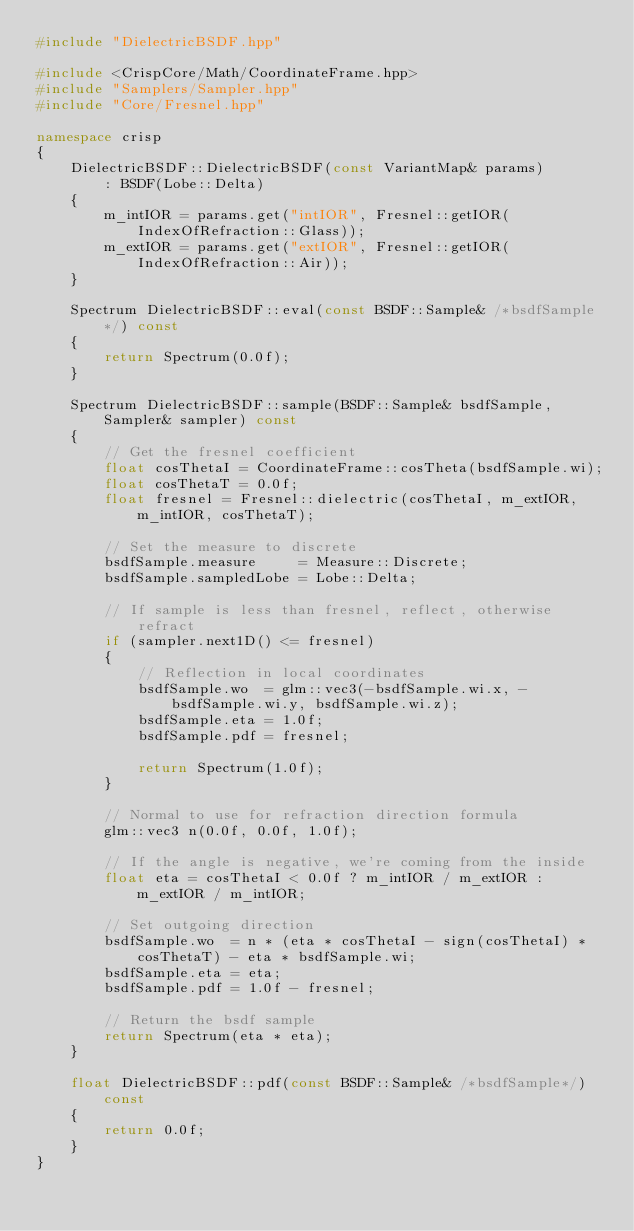Convert code to text. <code><loc_0><loc_0><loc_500><loc_500><_C++_>#include "DielectricBSDF.hpp"

#include <CrispCore/Math/CoordinateFrame.hpp>
#include "Samplers/Sampler.hpp"
#include "Core/Fresnel.hpp"

namespace crisp
{
    DielectricBSDF::DielectricBSDF(const VariantMap& params)
        : BSDF(Lobe::Delta)
    {
        m_intIOR = params.get("intIOR", Fresnel::getIOR(IndexOfRefraction::Glass));
        m_extIOR = params.get("extIOR", Fresnel::getIOR(IndexOfRefraction::Air));
    }

    Spectrum DielectricBSDF::eval(const BSDF::Sample& /*bsdfSample*/) const
    {
        return Spectrum(0.0f);
    }

    Spectrum DielectricBSDF::sample(BSDF::Sample& bsdfSample, Sampler& sampler) const
    {
        // Get the fresnel coefficient
        float cosThetaI = CoordinateFrame::cosTheta(bsdfSample.wi);
        float cosThetaT = 0.0f;
        float fresnel = Fresnel::dielectric(cosThetaI, m_extIOR, m_intIOR, cosThetaT);

        // Set the measure to discrete
        bsdfSample.measure     = Measure::Discrete;
        bsdfSample.sampledLobe = Lobe::Delta;

        // If sample is less than fresnel, reflect, otherwise refract
        if (sampler.next1D() <= fresnel)
        {
            // Reflection in local coordinates
            bsdfSample.wo  = glm::vec3(-bsdfSample.wi.x, -bsdfSample.wi.y, bsdfSample.wi.z);
            bsdfSample.eta = 1.0f;
            bsdfSample.pdf = fresnel;

            return Spectrum(1.0f);
        }

        // Normal to use for refraction direction formula
        glm::vec3 n(0.0f, 0.0f, 1.0f);

        // If the angle is negative, we're coming from the inside
        float eta = cosThetaI < 0.0f ? m_intIOR / m_extIOR : m_extIOR / m_intIOR;

        // Set outgoing direction
        bsdfSample.wo  = n * (eta * cosThetaI - sign(cosThetaI) * cosThetaT) - eta * bsdfSample.wi;
        bsdfSample.eta = eta;
        bsdfSample.pdf = 1.0f - fresnel;

        // Return the bsdf sample
        return Spectrum(eta * eta);
    }

    float DielectricBSDF::pdf(const BSDF::Sample& /*bsdfSample*/) const
    {
        return 0.0f;
    }
}</code> 